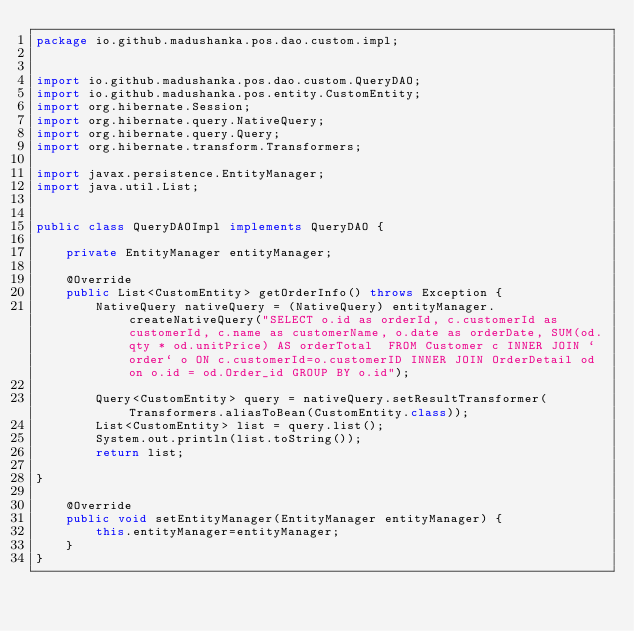<code> <loc_0><loc_0><loc_500><loc_500><_Java_>package io.github.madushanka.pos.dao.custom.impl;


import io.github.madushanka.pos.dao.custom.QueryDAO;
import io.github.madushanka.pos.entity.CustomEntity;
import org.hibernate.Session;
import org.hibernate.query.NativeQuery;
import org.hibernate.query.Query;
import org.hibernate.transform.Transformers;

import javax.persistence.EntityManager;
import java.util.List;


public class QueryDAOImpl implements QueryDAO {

    private EntityManager entityManager;

    @Override
    public List<CustomEntity> getOrderInfo() throws Exception {
        NativeQuery nativeQuery = (NativeQuery) entityManager.createNativeQuery("SELECT o.id as orderId, c.customerId as customerId, c.name as customerName, o.date as orderDate, SUM(od.qty * od.unitPrice) AS orderTotal  FROM Customer c INNER JOIN `order` o ON c.customerId=o.customerID INNER JOIN OrderDetail od on o.id = od.Order_id GROUP BY o.id");

        Query<CustomEntity> query = nativeQuery.setResultTransformer(Transformers.aliasToBean(CustomEntity.class));
        List<CustomEntity> list = query.list();
        System.out.println(list.toString());
        return list;

}

    @Override
    public void setEntityManager(EntityManager entityManager) {
        this.entityManager=entityManager;
    }
}
</code> 